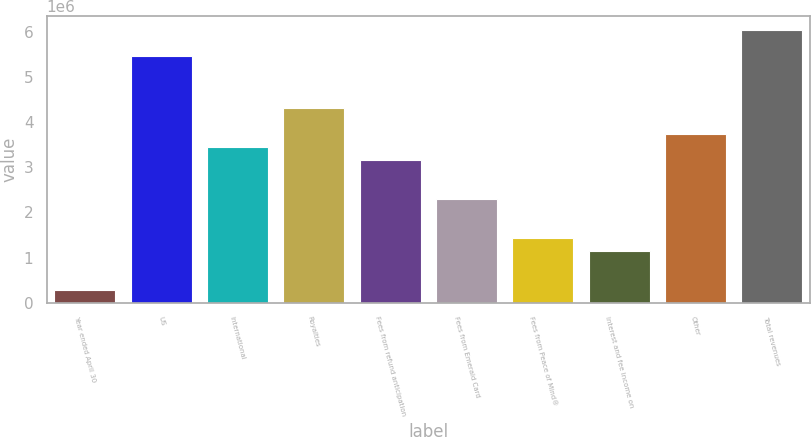Convert chart to OTSL. <chart><loc_0><loc_0><loc_500><loc_500><bar_chart><fcel>Year ended April 30<fcel>US<fcel>International<fcel>Royalties<fcel>Fees from refund anticipation<fcel>Fees from Emerald Card<fcel>Fees from Peace of Mind®<fcel>Interest and fee income on<fcel>Other<fcel>Total revenues<nl><fcel>287822<fcel>5.46811e+06<fcel>3.45355e+06<fcel>4.31694e+06<fcel>3.16576e+06<fcel>2.30238e+06<fcel>1.439e+06<fcel>1.1512e+06<fcel>3.74135e+06<fcel>6.0437e+06<nl></chart> 